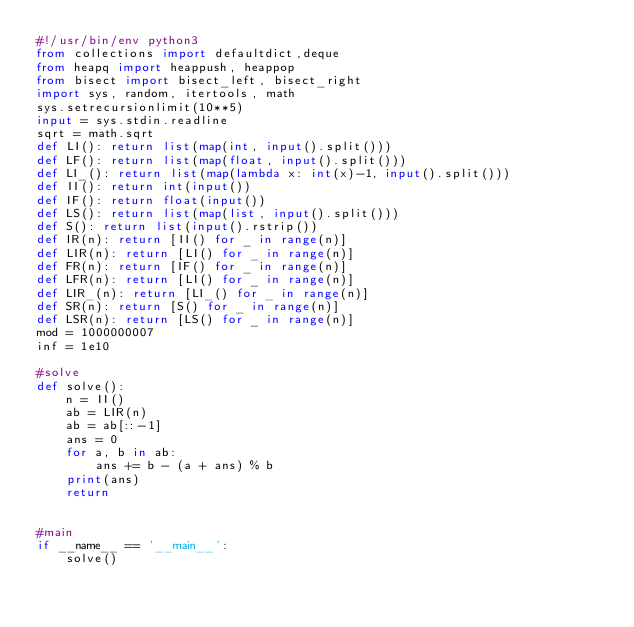Convert code to text. <code><loc_0><loc_0><loc_500><loc_500><_Python_>#!/usr/bin/env python3
from collections import defaultdict,deque
from heapq import heappush, heappop
from bisect import bisect_left, bisect_right
import sys, random, itertools, math
sys.setrecursionlimit(10**5)
input = sys.stdin.readline
sqrt = math.sqrt
def LI(): return list(map(int, input().split()))
def LF(): return list(map(float, input().split()))
def LI_(): return list(map(lambda x: int(x)-1, input().split()))
def II(): return int(input())
def IF(): return float(input())
def LS(): return list(map(list, input().split()))
def S(): return list(input().rstrip())
def IR(n): return [II() for _ in range(n)]
def LIR(n): return [LI() for _ in range(n)]
def FR(n): return [IF() for _ in range(n)]
def LFR(n): return [LI() for _ in range(n)]
def LIR_(n): return [LI_() for _ in range(n)]
def SR(n): return [S() for _ in range(n)]
def LSR(n): return [LS() for _ in range(n)]
mod = 1000000007
inf = 1e10

#solve
def solve():
    n = II()
    ab = LIR(n)
    ab = ab[::-1]
    ans = 0
    for a, b in ab:
        ans += b - (a + ans) % b
    print(ans)
    return


#main
if __name__ == '__main__':
    solve()
</code> 